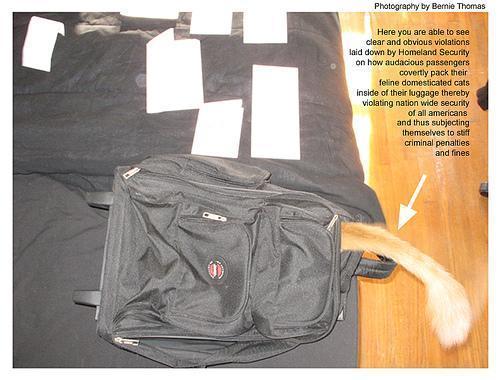How many cats are in the bag?
Give a very brief answer. 1. 